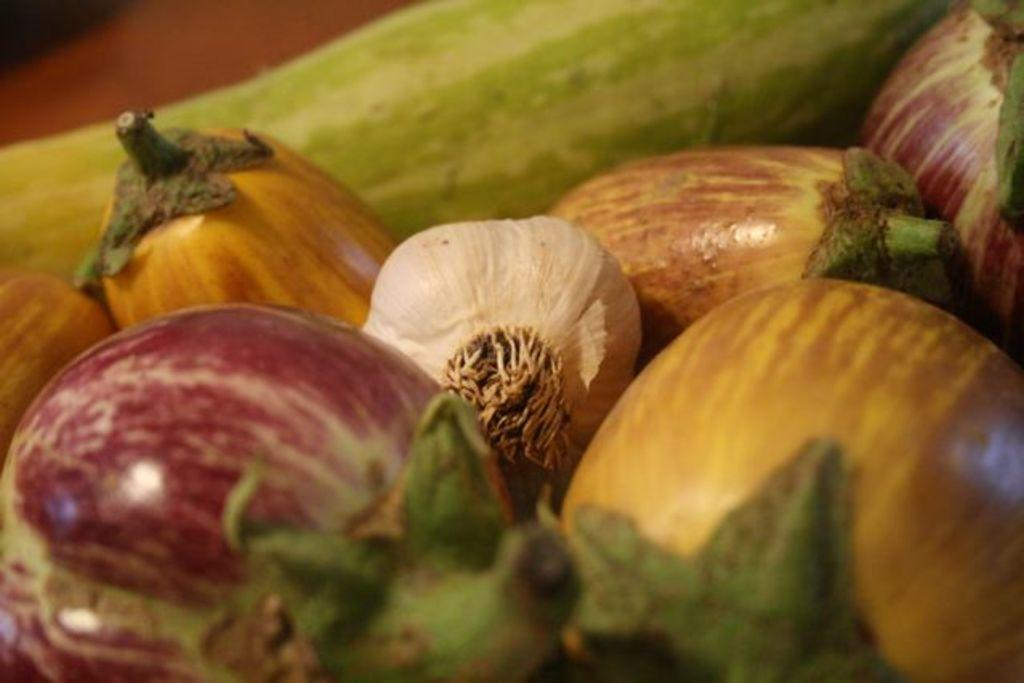What type of vegetables are present in the image? There are cucumbers, onions, and a bottle gourd in the image. Can you describe the appearance of the vegetables in the image? The cucumbers are long and green, the onions are round and brown, and the bottle gourd is large and green. What type of dress is the cucumber wearing in the image? There are no people or clothing items present in the image, so it is not possible to determine what type of dress a cucumber might be wearing. 